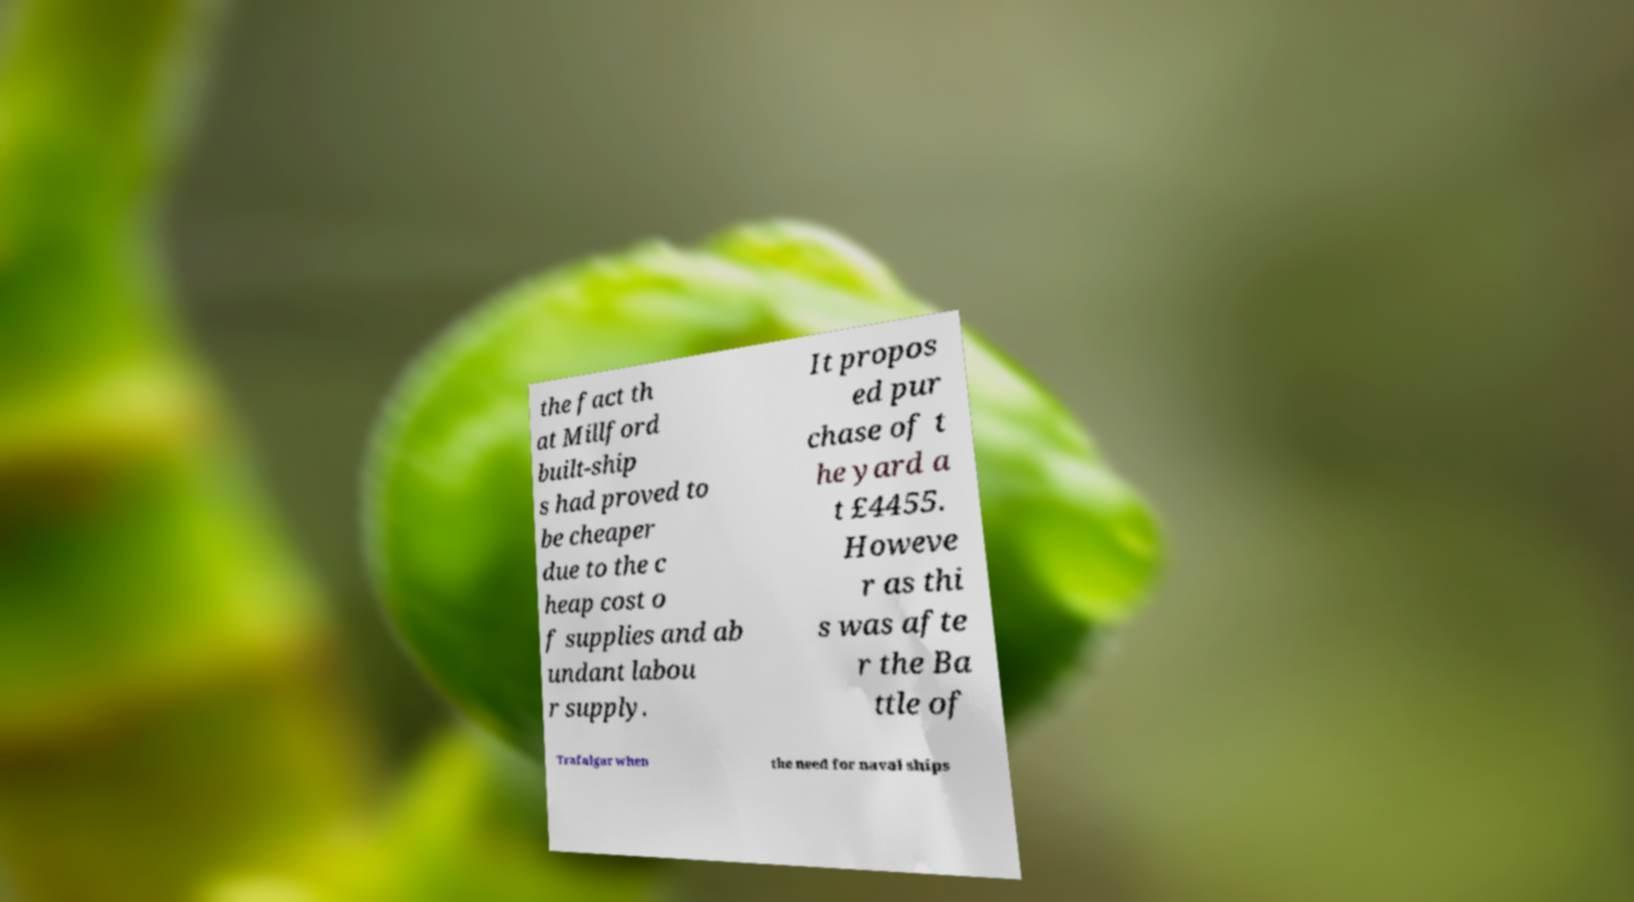There's text embedded in this image that I need extracted. Can you transcribe it verbatim? the fact th at Millford built-ship s had proved to be cheaper due to the c heap cost o f supplies and ab undant labou r supply. It propos ed pur chase of t he yard a t £4455. Howeve r as thi s was afte r the Ba ttle of Trafalgar when the need for naval ships 